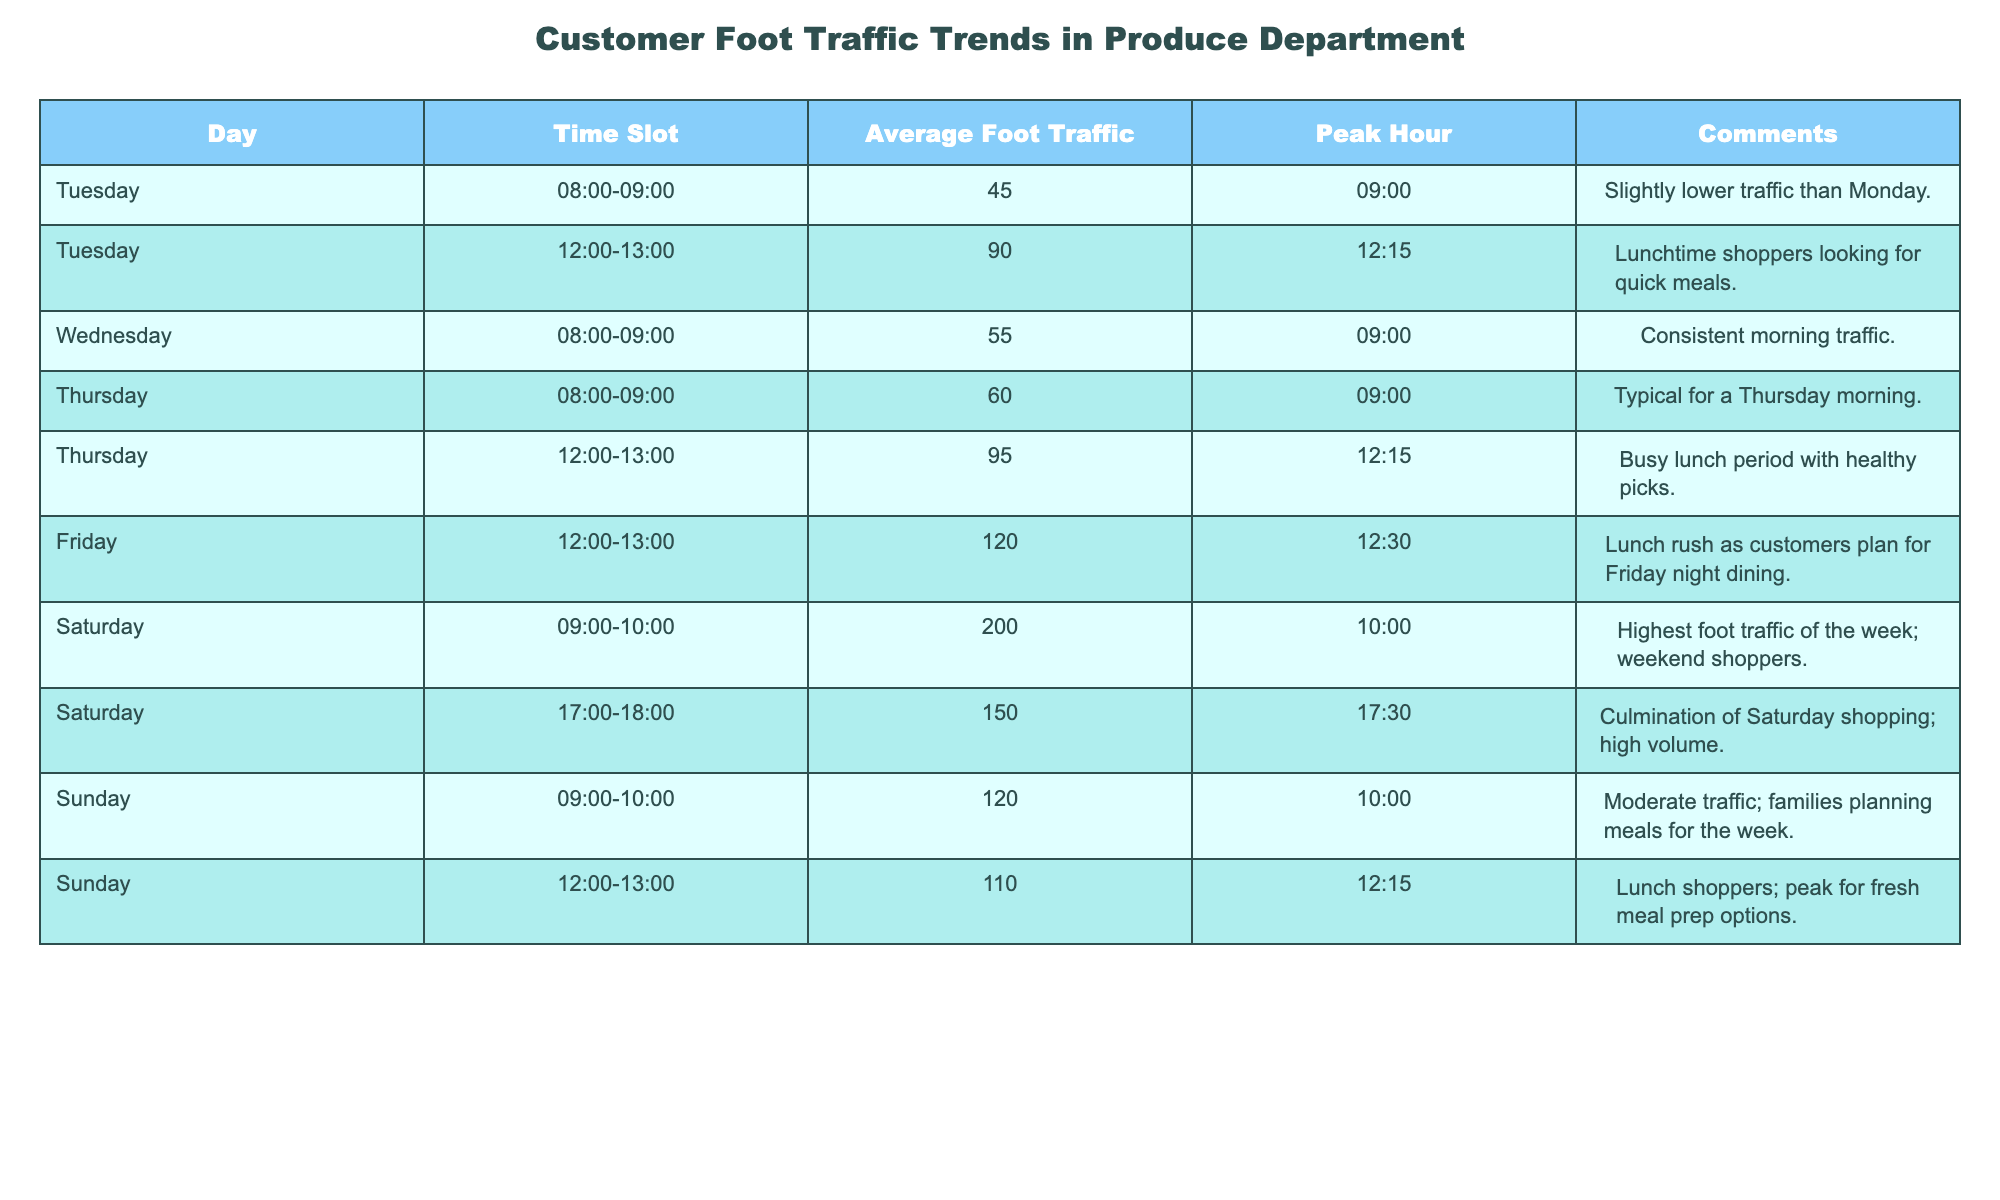What is the average foot traffic on Saturdays? To find the average foot traffic on Saturdays, I will first identify the foot traffic values for Saturday, which are 200 (09:00-10:00) and 150 (17:00-18:00). Next, I will add these values (200 + 150 = 350) and divide by the number of time slots (2). So, the average is 350 / 2 = 175.
Answer: 175 What day has the highest peak hour foot traffic? By examining the 'Peak Hour' column, I see that the highest peak hour foot traffic is 200 during Saturday from 09:00-10:00. Therefore, Saturday is the day with the highest peak hour foot traffic.
Answer: Saturday Was Tuesday's average foot traffic higher than Thursday? I will compare Tuesday's average foot traffic (45 in the 08:00-09:00 slot and 90 in the 12:00-13:00 slot, giving an average of (45 + 90) / 2 = 67.5) with Thursday's (60 in the 08:00-09:00 and 95 in the 12:00-13:00, giving an average of (60 + 95) / 2 = 77.5). Since 67.5 is not higher than 77.5, the answer is no.
Answer: No What is the total average foot traffic during lunch hours (12:00-13:00) across all days? To calculate the total average foot traffic during lunch hours, I'll note the foot traffic values for each day during this time slot: Tuesday (90), Thursday (95), Friday (120), Sunday (110). Summing these values gives 90 + 95 + 120 + 110 = 415. Since there are 4 days, the average is 415 / 4 = 103.75.
Answer: 103.75 Is the foot traffic on Sunday’s 09:00-10:00 less than or equal to Tuesday’s 08:00-09:00? I will compare Sunday’s 09:00-10:00 foot traffic (120) with Tuesday’s 08:00-09:00 foot traffic (45). Since 120 is greater than 45, the answer is no.
Answer: No Which time slot in the week has the most significant difference in average foot traffic compared to others? I will look for the time slot with the highest foot traffic and compare it with others. Saturday 09:00-10:00 has 200, significantly higher than the next highest, which is Friday 12:00-13:00 at 120. The difference is 200 - 120 = 80, making this the most significant difference.
Answer: Saturday 09:00-10:00 What time slot has average foot traffic close to 100? I will examine the table, particularly the foot traffic values around 100. The time slots 12:00-13:00 on Thursday (95) and Sunday (110) are the closest, but it appears Sunday 12:00-13:00 is precisely above 100, so this is my answer.
Answer: Sunday 12:00-13:00 